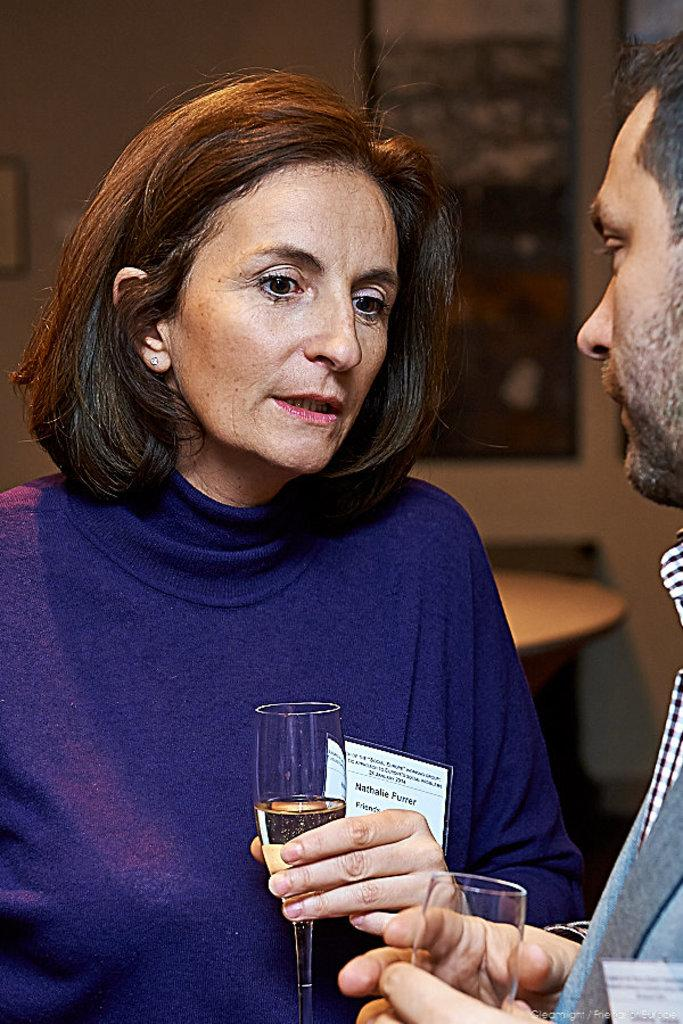Who are the people in the image? There is a woman and a man in the image. What are the woman and the man holding? They are both holding glasses. What can be seen in the background of the image? There is a wall in the background of the image. Can you describe any other objects in the image? Yes, there is a frame in the image. What type of tax is being discussed by the woman and the man in the image? There is no indication in the image that the woman and the man are discussing any type of tax. --- Facts: 1. There is a car in the image. 2. The car is red. 3. The car has four wheels. 4. There is a road in the image. 5. The road is paved. Absurd Topics: bird, ocean, mountain Conversation: What is the main subject of the image? The main subject of the image is a car. What color is the car? The car is red. How many wheels does the car have? The car has four wheels. What can be seen in the background of the image? There is a road in the image. What is the condition of the road? The road is paved. Reasoning: Let's think step by step in order to produce the conversation. We start by identifying the main subject in the image, which is the car. Then, we describe the car's color and the number of wheels it has. Next, we mention the background of the image, which includes a road. Finally, we acknowledge the condition of the road, which is paved. Each question is designed to elicit a specific detail about the image that is known from the provided facts. Absurd Question/Answer: Can you see any mountains in the image? There are no mountains visible in the image; it features a red car and a paved road. 